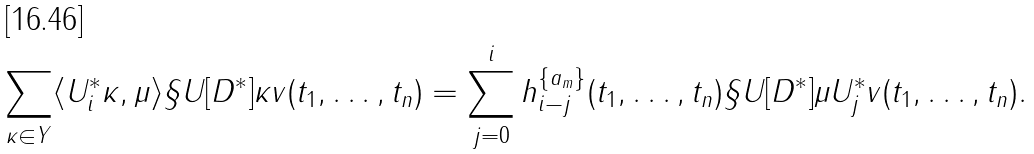<formula> <loc_0><loc_0><loc_500><loc_500>\sum _ { \kappa \in Y } \langle U ^ { \ast } _ { i } \kappa , \mu \rangle \S U [ D ^ { \ast } ] { \kappa } { v } ( t _ { 1 } , \dots , t _ { n } ) = \sum _ { j = 0 } ^ { i } h _ { i - j } ^ { \{ a _ { m } \} } ( t _ { 1 } , \dots , t _ { n } ) \S U [ D ^ { \ast } ] { \mu } { U ^ { \ast } _ { j } v } ( t _ { 1 } , \dots , t _ { n } ) .</formula> 